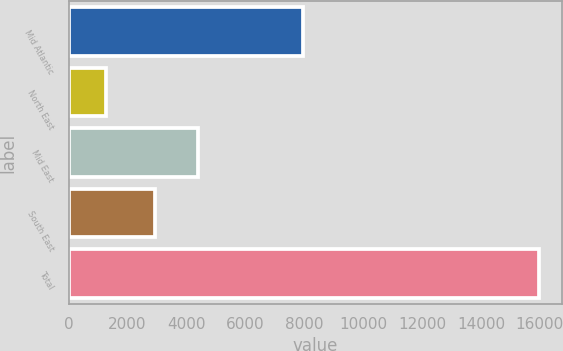Convert chart to OTSL. <chart><loc_0><loc_0><loc_500><loc_500><bar_chart><fcel>Mid Atlantic<fcel>North East<fcel>Mid East<fcel>South East<fcel>Total<nl><fcel>7971<fcel>1288<fcel>4397.3<fcel>2930<fcel>15961<nl></chart> 